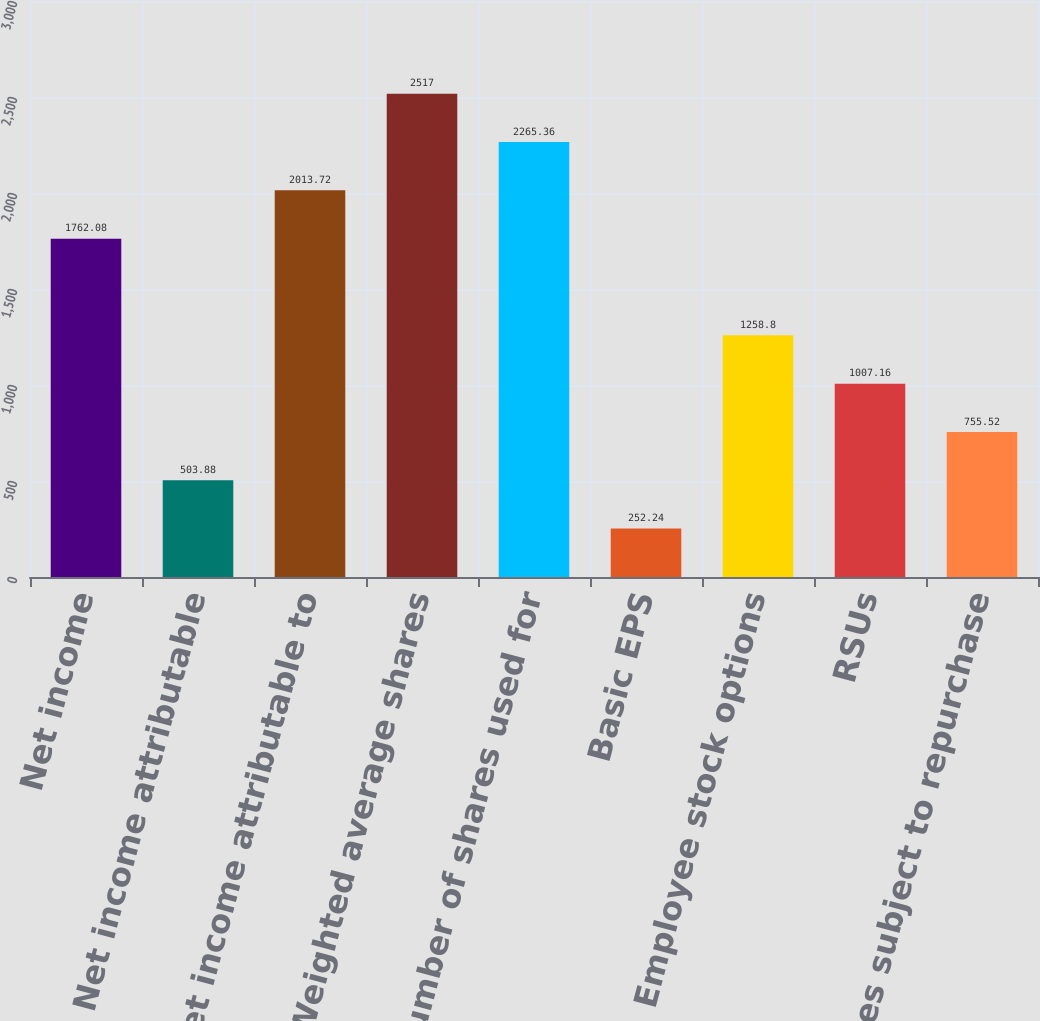<chart> <loc_0><loc_0><loc_500><loc_500><bar_chart><fcel>Net income<fcel>Less Net income attributable<fcel>Net income attributable to<fcel>Weighted average shares<fcel>Number of shares used for<fcel>Basic EPS<fcel>Employee stock options<fcel>RSUs<fcel>Shares subject to repurchase<nl><fcel>1762.08<fcel>503.88<fcel>2013.72<fcel>2517<fcel>2265.36<fcel>252.24<fcel>1258.8<fcel>1007.16<fcel>755.52<nl></chart> 